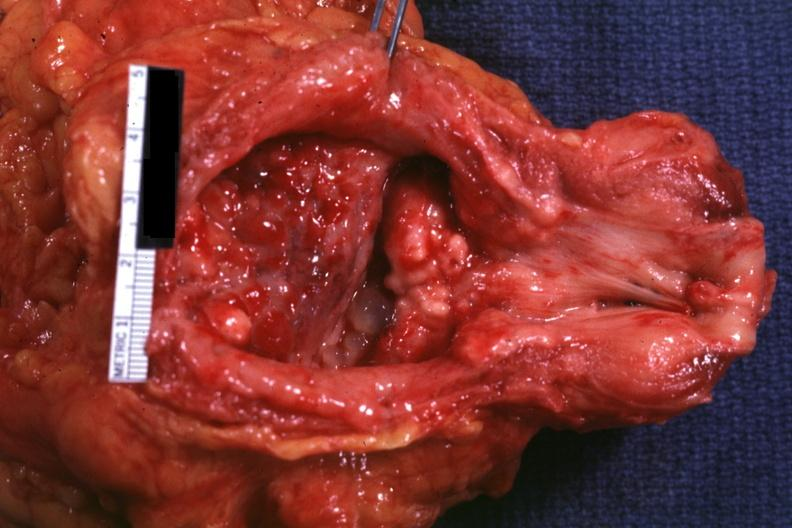does this image show opened bladder and urethra with granular tumor masses visible in floor of bladder quite good?
Answer the question using a single word or phrase. Yes 